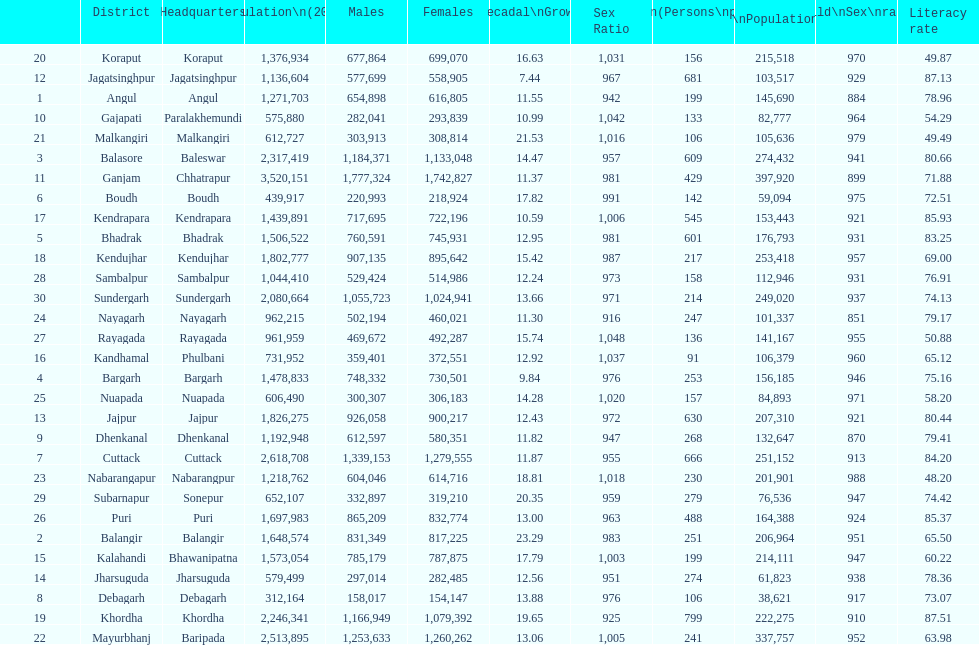What is the difference in child population between koraput and puri? 51,130. Parse the table in full. {'header': ['', 'District', 'Headquarters', 'Population\\n(2011)', 'Males', 'Females', 'Percentage\\nDecadal\\nGrowth\\n2001-2011', 'Sex Ratio', 'Density\\n(Persons\\nper\\nkm2)', 'Child\\nPopulation\\n0–6 years', 'Child\\nSex\\nratio', 'Literacy rate'], 'rows': [['20', 'Koraput', 'Koraput', '1,376,934', '677,864', '699,070', '16.63', '1,031', '156', '215,518', '970', '49.87'], ['12', 'Jagatsinghpur', 'Jagatsinghpur', '1,136,604', '577,699', '558,905', '7.44', '967', '681', '103,517', '929', '87.13'], ['1', 'Angul', 'Angul', '1,271,703', '654,898', '616,805', '11.55', '942', '199', '145,690', '884', '78.96'], ['10', 'Gajapati', 'Paralakhemundi', '575,880', '282,041', '293,839', '10.99', '1,042', '133', '82,777', '964', '54.29'], ['21', 'Malkangiri', 'Malkangiri', '612,727', '303,913', '308,814', '21.53', '1,016', '106', '105,636', '979', '49.49'], ['3', 'Balasore', 'Baleswar', '2,317,419', '1,184,371', '1,133,048', '14.47', '957', '609', '274,432', '941', '80.66'], ['11', 'Ganjam', 'Chhatrapur', '3,520,151', '1,777,324', '1,742,827', '11.37', '981', '429', '397,920', '899', '71.88'], ['6', 'Boudh', 'Boudh', '439,917', '220,993', '218,924', '17.82', '991', '142', '59,094', '975', '72.51'], ['17', 'Kendrapara', 'Kendrapara', '1,439,891', '717,695', '722,196', '10.59', '1,006', '545', '153,443', '921', '85.93'], ['5', 'Bhadrak', 'Bhadrak', '1,506,522', '760,591', '745,931', '12.95', '981', '601', '176,793', '931', '83.25'], ['18', 'Kendujhar', 'Kendujhar', '1,802,777', '907,135', '895,642', '15.42', '987', '217', '253,418', '957', '69.00'], ['28', 'Sambalpur', 'Sambalpur', '1,044,410', '529,424', '514,986', '12.24', '973', '158', '112,946', '931', '76.91'], ['30', 'Sundergarh', 'Sundergarh', '2,080,664', '1,055,723', '1,024,941', '13.66', '971', '214', '249,020', '937', '74.13'], ['24', 'Nayagarh', 'Nayagarh', '962,215', '502,194', '460,021', '11.30', '916', '247', '101,337', '851', '79.17'], ['27', 'Rayagada', 'Rayagada', '961,959', '469,672', '492,287', '15.74', '1,048', '136', '141,167', '955', '50.88'], ['16', 'Kandhamal', 'Phulbani', '731,952', '359,401', '372,551', '12.92', '1,037', '91', '106,379', '960', '65.12'], ['4', 'Bargarh', 'Bargarh', '1,478,833', '748,332', '730,501', '9.84', '976', '253', '156,185', '946', '75.16'], ['25', 'Nuapada', 'Nuapada', '606,490', '300,307', '306,183', '14.28', '1,020', '157', '84,893', '971', '58.20'], ['13', 'Jajpur', 'Jajpur', '1,826,275', '926,058', '900,217', '12.43', '972', '630', '207,310', '921', '80.44'], ['9', 'Dhenkanal', 'Dhenkanal', '1,192,948', '612,597', '580,351', '11.82', '947', '268', '132,647', '870', '79.41'], ['7', 'Cuttack', 'Cuttack', '2,618,708', '1,339,153', '1,279,555', '11.87', '955', '666', '251,152', '913', '84.20'], ['23', 'Nabarangapur', 'Nabarangpur', '1,218,762', '604,046', '614,716', '18.81', '1,018', '230', '201,901', '988', '48.20'], ['29', 'Subarnapur', 'Sonepur', '652,107', '332,897', '319,210', '20.35', '959', '279', '76,536', '947', '74.42'], ['26', 'Puri', 'Puri', '1,697,983', '865,209', '832,774', '13.00', '963', '488', '164,388', '924', '85.37'], ['2', 'Balangir', 'Balangir', '1,648,574', '831,349', '817,225', '23.29', '983', '251', '206,964', '951', '65.50'], ['15', 'Kalahandi', 'Bhawanipatna', '1,573,054', '785,179', '787,875', '17.79', '1,003', '199', '214,111', '947', '60.22'], ['14', 'Jharsuguda', 'Jharsuguda', '579,499', '297,014', '282,485', '12.56', '951', '274', '61,823', '938', '78.36'], ['8', 'Debagarh', 'Debagarh', '312,164', '158,017', '154,147', '13.88', '976', '106', '38,621', '917', '73.07'], ['19', 'Khordha', 'Khordha', '2,246,341', '1,166,949', '1,079,392', '19.65', '925', '799', '222,275', '910', '87.51'], ['22', 'Mayurbhanj', 'Baripada', '2,513,895', '1,253,633', '1,260,262', '13.06', '1,005', '241', '337,757', '952', '63.98']]} 